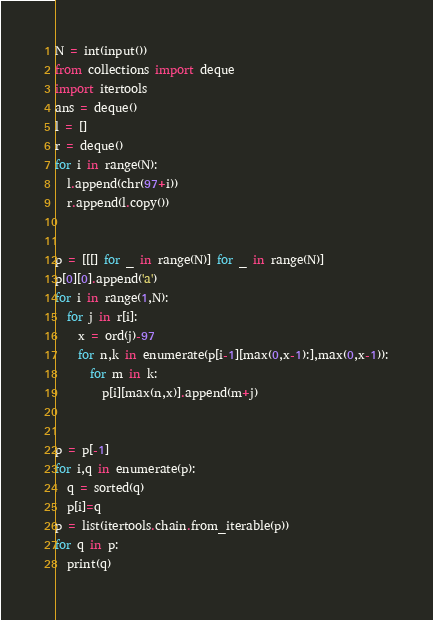<code> <loc_0><loc_0><loc_500><loc_500><_Python_>N = int(input())
from collections import deque
import itertools
ans = deque()
l = []
r = deque()
for i in range(N):
  l.append(chr(97+i))
  r.append(l.copy())
  

p = [[[] for _ in range(N)] for _ in range(N)]
p[0][0].append('a')
for i in range(1,N):
  for j in r[i]:
    x = ord(j)-97
    for n,k in enumerate(p[i-1][max(0,x-1):],max(0,x-1)):
      for m in k:
        p[i][max(n,x)].append(m+j)


p = p[-1]
for i,q in enumerate(p):
  q = sorted(q)
  p[i]=q
p = list(itertools.chain.from_iterable(p))
for q in p:
  print(q)</code> 